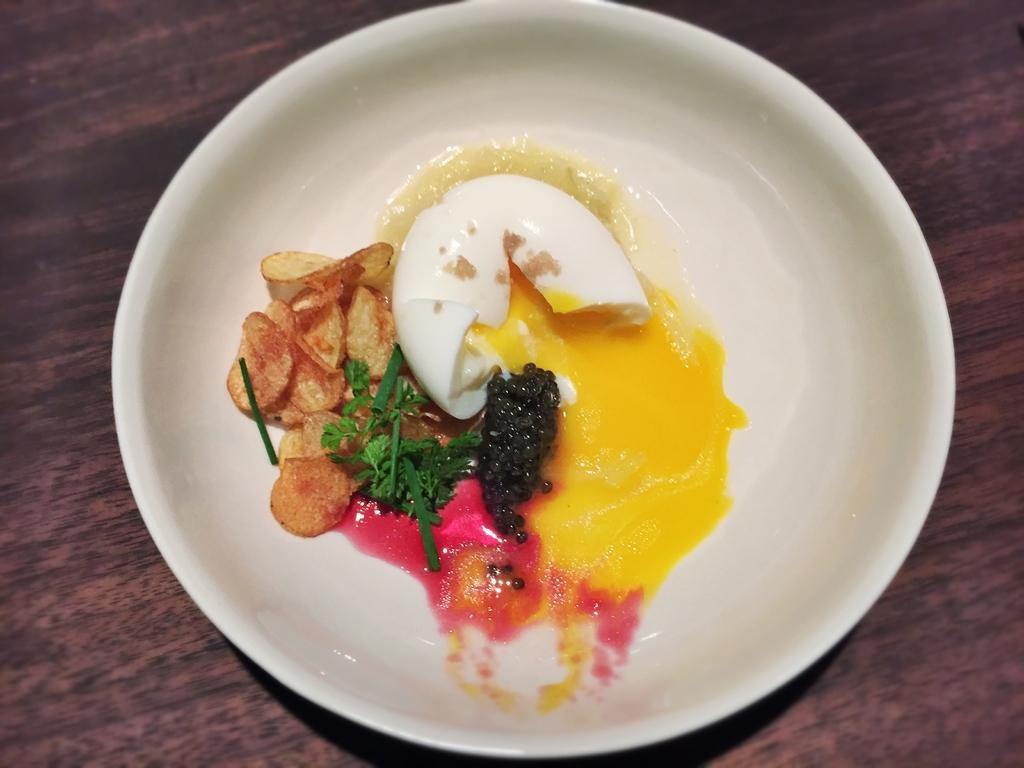Could you give a brief overview of what you see in this image? In this picture I can see food in the plate and I can see a wooden table 